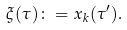Convert formula to latex. <formula><loc_0><loc_0><loc_500><loc_500>\xi ( \tau ) & \colon = x _ { k } ( \tau ^ { \prime } ) .</formula> 